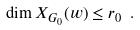Convert formula to latex. <formula><loc_0><loc_0><loc_500><loc_500>\dim X _ { G _ { 0 } } ( w ) \leq r _ { 0 } \ .</formula> 